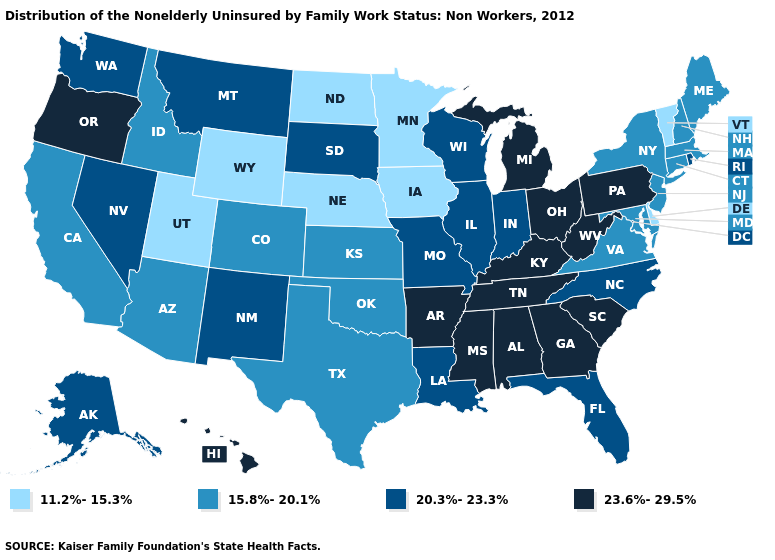Does South Carolina have a lower value than New Mexico?
Quick response, please. No. Does the first symbol in the legend represent the smallest category?
Quick response, please. Yes. Does Delaware have the highest value in the USA?
Answer briefly. No. What is the value of Louisiana?
Short answer required. 20.3%-23.3%. Name the states that have a value in the range 15.8%-20.1%?
Write a very short answer. Arizona, California, Colorado, Connecticut, Idaho, Kansas, Maine, Maryland, Massachusetts, New Hampshire, New Jersey, New York, Oklahoma, Texas, Virginia. What is the value of Vermont?
Quick response, please. 11.2%-15.3%. Name the states that have a value in the range 11.2%-15.3%?
Be succinct. Delaware, Iowa, Minnesota, Nebraska, North Dakota, Utah, Vermont, Wyoming. Does Vermont have the lowest value in the USA?
Keep it brief. Yes. Name the states that have a value in the range 15.8%-20.1%?
Write a very short answer. Arizona, California, Colorado, Connecticut, Idaho, Kansas, Maine, Maryland, Massachusetts, New Hampshire, New Jersey, New York, Oklahoma, Texas, Virginia. Does Wisconsin have the same value as Florida?
Keep it brief. Yes. What is the lowest value in states that border New York?
Keep it brief. 11.2%-15.3%. Name the states that have a value in the range 11.2%-15.3%?
Keep it brief. Delaware, Iowa, Minnesota, Nebraska, North Dakota, Utah, Vermont, Wyoming. Does West Virginia have a lower value than Hawaii?
Answer briefly. No. Name the states that have a value in the range 15.8%-20.1%?
Short answer required. Arizona, California, Colorado, Connecticut, Idaho, Kansas, Maine, Maryland, Massachusetts, New Hampshire, New Jersey, New York, Oklahoma, Texas, Virginia. Does Connecticut have the highest value in the Northeast?
Quick response, please. No. 